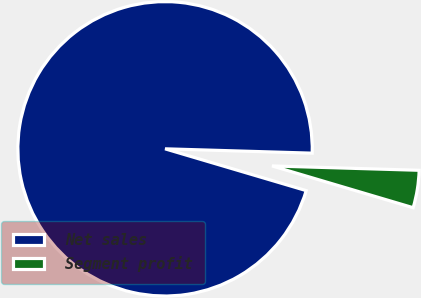Convert chart. <chart><loc_0><loc_0><loc_500><loc_500><pie_chart><fcel>Net sales<fcel>Segment profit<nl><fcel>95.89%<fcel>4.11%<nl></chart> 